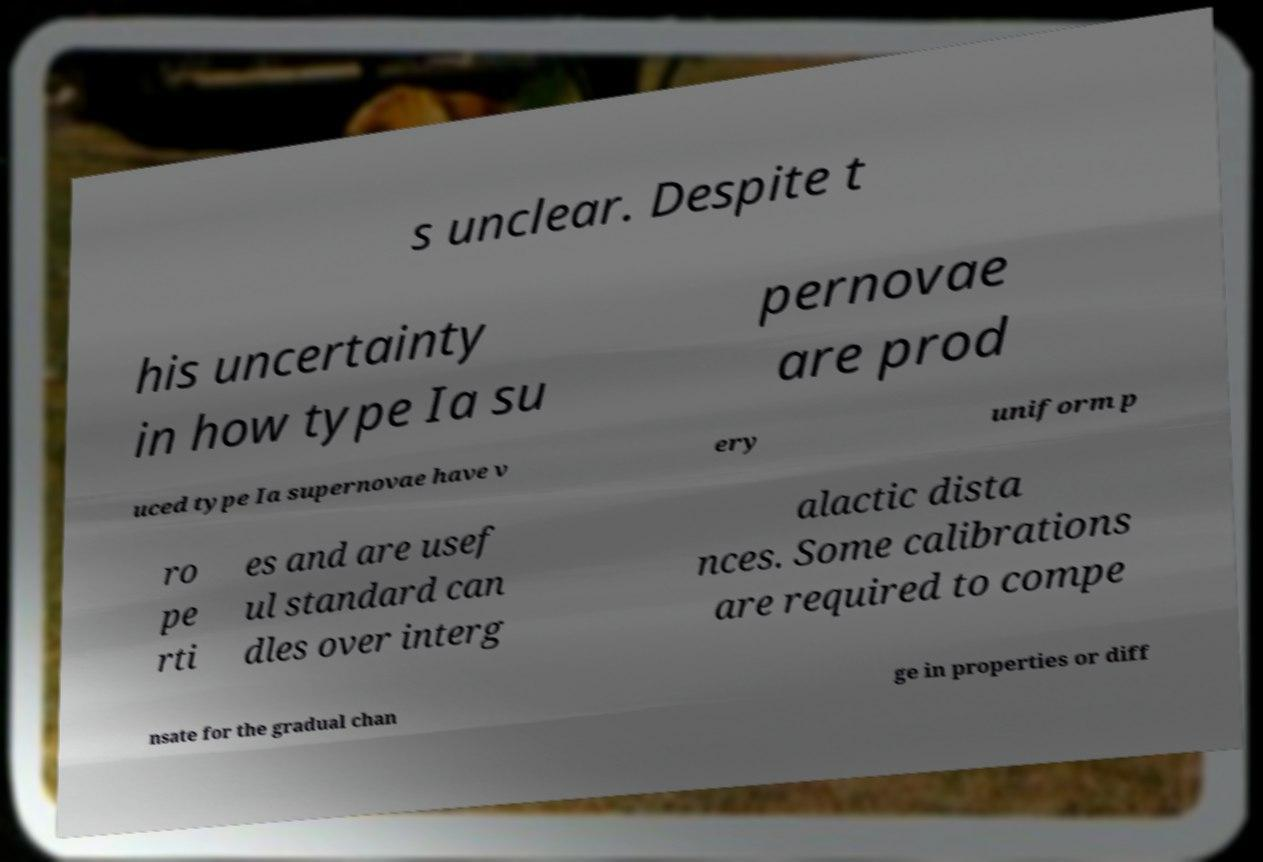Could you assist in decoding the text presented in this image and type it out clearly? s unclear. Despite t his uncertainty in how type Ia su pernovae are prod uced type Ia supernovae have v ery uniform p ro pe rti es and are usef ul standard can dles over interg alactic dista nces. Some calibrations are required to compe nsate for the gradual chan ge in properties or diff 